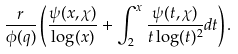Convert formula to latex. <formula><loc_0><loc_0><loc_500><loc_500>\frac { r } { \phi ( q ) } \left ( \frac { \psi ( x , \chi ) } { \log ( x ) } + \int _ { 2 } ^ { x } \frac { \psi ( t , \chi ) } { t \log ( t ) ^ { 2 } } d t \right ) .</formula> 